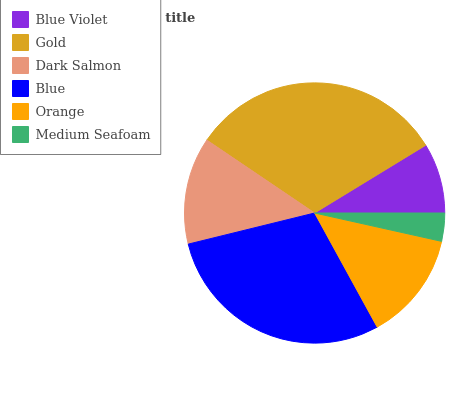Is Medium Seafoam the minimum?
Answer yes or no. Yes. Is Gold the maximum?
Answer yes or no. Yes. Is Dark Salmon the minimum?
Answer yes or no. No. Is Dark Salmon the maximum?
Answer yes or no. No. Is Gold greater than Dark Salmon?
Answer yes or no. Yes. Is Dark Salmon less than Gold?
Answer yes or no. Yes. Is Dark Salmon greater than Gold?
Answer yes or no. No. Is Gold less than Dark Salmon?
Answer yes or no. No. Is Orange the high median?
Answer yes or no. Yes. Is Dark Salmon the low median?
Answer yes or no. Yes. Is Medium Seafoam the high median?
Answer yes or no. No. Is Gold the low median?
Answer yes or no. No. 